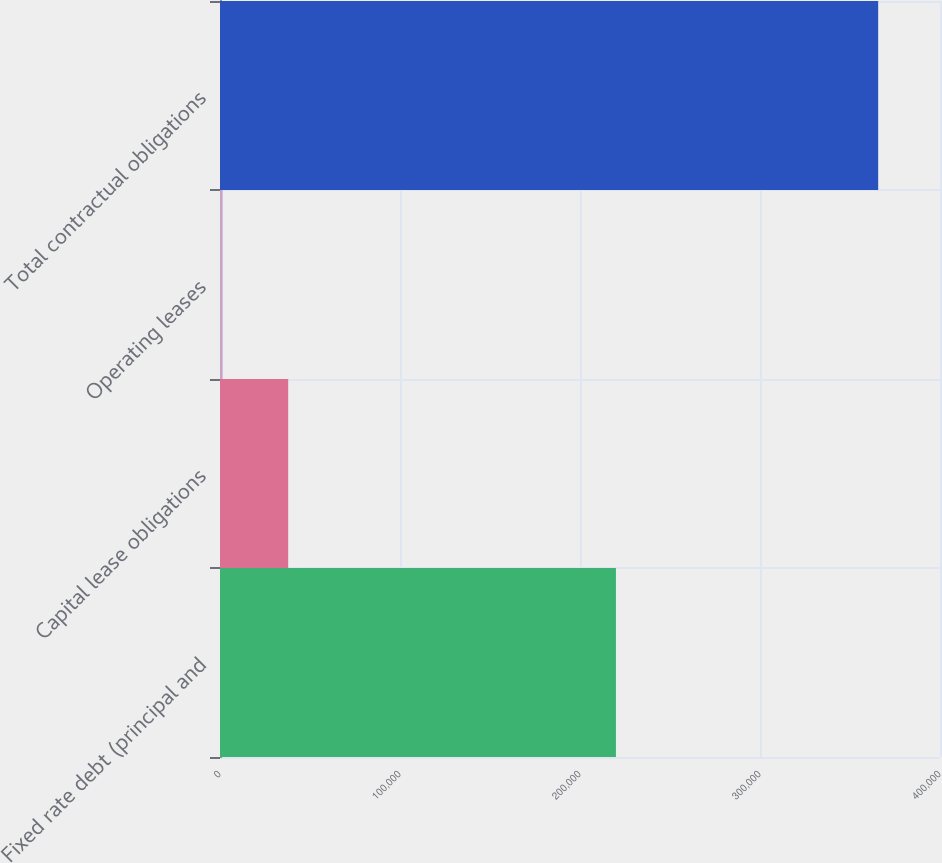Convert chart to OTSL. <chart><loc_0><loc_0><loc_500><loc_500><bar_chart><fcel>Fixed rate debt (principal and<fcel>Capital lease obligations<fcel>Operating leases<fcel>Total contractual obligations<nl><fcel>219961<fcel>37885.8<fcel>1467<fcel>365655<nl></chart> 